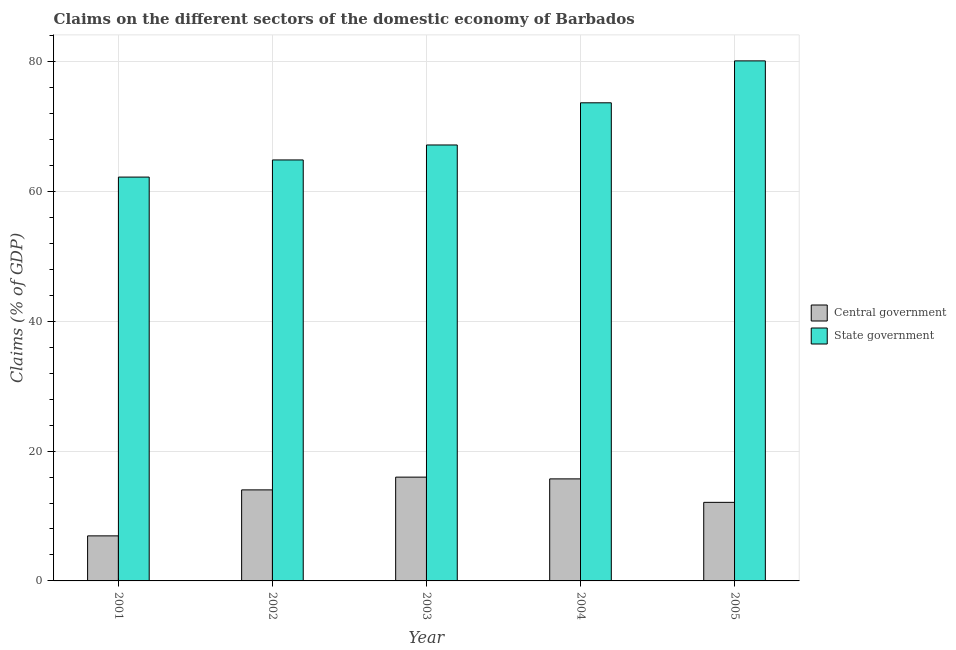How many different coloured bars are there?
Keep it short and to the point. 2. Are the number of bars per tick equal to the number of legend labels?
Offer a very short reply. Yes. Are the number of bars on each tick of the X-axis equal?
Keep it short and to the point. Yes. How many bars are there on the 1st tick from the right?
Provide a short and direct response. 2. What is the claims on state government in 2004?
Your response must be concise. 73.65. Across all years, what is the maximum claims on central government?
Make the answer very short. 15.99. Across all years, what is the minimum claims on central government?
Your answer should be very brief. 6.94. In which year was the claims on central government maximum?
Your response must be concise. 2003. In which year was the claims on central government minimum?
Provide a short and direct response. 2001. What is the total claims on central government in the graph?
Give a very brief answer. 64.77. What is the difference between the claims on central government in 2001 and that in 2003?
Your answer should be very brief. -9.05. What is the difference between the claims on state government in 2001 and the claims on central government in 2003?
Make the answer very short. -4.95. What is the average claims on central government per year?
Offer a very short reply. 12.95. What is the ratio of the claims on state government in 2002 to that in 2003?
Your response must be concise. 0.97. Is the claims on state government in 2001 less than that in 2002?
Ensure brevity in your answer.  Yes. What is the difference between the highest and the second highest claims on state government?
Offer a very short reply. 6.46. What is the difference between the highest and the lowest claims on central government?
Ensure brevity in your answer.  9.05. In how many years, is the claims on central government greater than the average claims on central government taken over all years?
Give a very brief answer. 3. What does the 2nd bar from the left in 2004 represents?
Provide a short and direct response. State government. What does the 1st bar from the right in 2003 represents?
Provide a succinct answer. State government. How many bars are there?
Ensure brevity in your answer.  10. Does the graph contain any zero values?
Provide a short and direct response. No. How many legend labels are there?
Provide a short and direct response. 2. How are the legend labels stacked?
Offer a very short reply. Vertical. What is the title of the graph?
Your answer should be very brief. Claims on the different sectors of the domestic economy of Barbados. Does "From human activities" appear as one of the legend labels in the graph?
Ensure brevity in your answer.  No. What is the label or title of the X-axis?
Your answer should be very brief. Year. What is the label or title of the Y-axis?
Ensure brevity in your answer.  Claims (% of GDP). What is the Claims (% of GDP) of Central government in 2001?
Provide a short and direct response. 6.94. What is the Claims (% of GDP) in State government in 2001?
Your response must be concise. 62.21. What is the Claims (% of GDP) in Central government in 2002?
Offer a very short reply. 14.02. What is the Claims (% of GDP) of State government in 2002?
Provide a succinct answer. 64.85. What is the Claims (% of GDP) of Central government in 2003?
Keep it short and to the point. 15.99. What is the Claims (% of GDP) of State government in 2003?
Give a very brief answer. 67.15. What is the Claims (% of GDP) of Central government in 2004?
Provide a short and direct response. 15.72. What is the Claims (% of GDP) of State government in 2004?
Ensure brevity in your answer.  73.65. What is the Claims (% of GDP) of Central government in 2005?
Make the answer very short. 12.1. What is the Claims (% of GDP) of State government in 2005?
Provide a short and direct response. 80.11. Across all years, what is the maximum Claims (% of GDP) of Central government?
Your response must be concise. 15.99. Across all years, what is the maximum Claims (% of GDP) of State government?
Provide a short and direct response. 80.11. Across all years, what is the minimum Claims (% of GDP) of Central government?
Offer a very short reply. 6.94. Across all years, what is the minimum Claims (% of GDP) in State government?
Keep it short and to the point. 62.21. What is the total Claims (% of GDP) of Central government in the graph?
Your answer should be compact. 64.77. What is the total Claims (% of GDP) of State government in the graph?
Make the answer very short. 347.97. What is the difference between the Claims (% of GDP) in Central government in 2001 and that in 2002?
Give a very brief answer. -7.08. What is the difference between the Claims (% of GDP) in State government in 2001 and that in 2002?
Give a very brief answer. -2.64. What is the difference between the Claims (% of GDP) in Central government in 2001 and that in 2003?
Keep it short and to the point. -9.05. What is the difference between the Claims (% of GDP) of State government in 2001 and that in 2003?
Provide a short and direct response. -4.95. What is the difference between the Claims (% of GDP) in Central government in 2001 and that in 2004?
Your answer should be very brief. -8.78. What is the difference between the Claims (% of GDP) in State government in 2001 and that in 2004?
Keep it short and to the point. -11.44. What is the difference between the Claims (% of GDP) of Central government in 2001 and that in 2005?
Offer a very short reply. -5.16. What is the difference between the Claims (% of GDP) in State government in 2001 and that in 2005?
Keep it short and to the point. -17.9. What is the difference between the Claims (% of GDP) of Central government in 2002 and that in 2003?
Make the answer very short. -1.97. What is the difference between the Claims (% of GDP) in State government in 2002 and that in 2003?
Give a very brief answer. -2.31. What is the difference between the Claims (% of GDP) of Central government in 2002 and that in 2004?
Ensure brevity in your answer.  -1.7. What is the difference between the Claims (% of GDP) in State government in 2002 and that in 2004?
Ensure brevity in your answer.  -8.8. What is the difference between the Claims (% of GDP) in Central government in 2002 and that in 2005?
Your response must be concise. 1.92. What is the difference between the Claims (% of GDP) in State government in 2002 and that in 2005?
Keep it short and to the point. -15.26. What is the difference between the Claims (% of GDP) of Central government in 2003 and that in 2004?
Provide a succinct answer. 0.27. What is the difference between the Claims (% of GDP) of State government in 2003 and that in 2004?
Your response must be concise. -6.5. What is the difference between the Claims (% of GDP) in Central government in 2003 and that in 2005?
Provide a short and direct response. 3.88. What is the difference between the Claims (% of GDP) of State government in 2003 and that in 2005?
Keep it short and to the point. -12.95. What is the difference between the Claims (% of GDP) in Central government in 2004 and that in 2005?
Ensure brevity in your answer.  3.62. What is the difference between the Claims (% of GDP) of State government in 2004 and that in 2005?
Provide a short and direct response. -6.46. What is the difference between the Claims (% of GDP) in Central government in 2001 and the Claims (% of GDP) in State government in 2002?
Offer a terse response. -57.91. What is the difference between the Claims (% of GDP) in Central government in 2001 and the Claims (% of GDP) in State government in 2003?
Provide a short and direct response. -60.21. What is the difference between the Claims (% of GDP) in Central government in 2001 and the Claims (% of GDP) in State government in 2004?
Ensure brevity in your answer.  -66.71. What is the difference between the Claims (% of GDP) of Central government in 2001 and the Claims (% of GDP) of State government in 2005?
Provide a succinct answer. -73.17. What is the difference between the Claims (% of GDP) of Central government in 2002 and the Claims (% of GDP) of State government in 2003?
Provide a short and direct response. -53.13. What is the difference between the Claims (% of GDP) in Central government in 2002 and the Claims (% of GDP) in State government in 2004?
Your answer should be compact. -59.63. What is the difference between the Claims (% of GDP) of Central government in 2002 and the Claims (% of GDP) of State government in 2005?
Ensure brevity in your answer.  -66.09. What is the difference between the Claims (% of GDP) in Central government in 2003 and the Claims (% of GDP) in State government in 2004?
Offer a very short reply. -57.66. What is the difference between the Claims (% of GDP) of Central government in 2003 and the Claims (% of GDP) of State government in 2005?
Provide a short and direct response. -64.12. What is the difference between the Claims (% of GDP) of Central government in 2004 and the Claims (% of GDP) of State government in 2005?
Your answer should be compact. -64.39. What is the average Claims (% of GDP) of Central government per year?
Your answer should be very brief. 12.95. What is the average Claims (% of GDP) of State government per year?
Offer a terse response. 69.59. In the year 2001, what is the difference between the Claims (% of GDP) of Central government and Claims (% of GDP) of State government?
Provide a succinct answer. -55.27. In the year 2002, what is the difference between the Claims (% of GDP) in Central government and Claims (% of GDP) in State government?
Make the answer very short. -50.83. In the year 2003, what is the difference between the Claims (% of GDP) of Central government and Claims (% of GDP) of State government?
Make the answer very short. -51.17. In the year 2004, what is the difference between the Claims (% of GDP) of Central government and Claims (% of GDP) of State government?
Your answer should be compact. -57.93. In the year 2005, what is the difference between the Claims (% of GDP) in Central government and Claims (% of GDP) in State government?
Offer a very short reply. -68. What is the ratio of the Claims (% of GDP) in Central government in 2001 to that in 2002?
Your answer should be compact. 0.49. What is the ratio of the Claims (% of GDP) in State government in 2001 to that in 2002?
Your answer should be very brief. 0.96. What is the ratio of the Claims (% of GDP) in Central government in 2001 to that in 2003?
Provide a succinct answer. 0.43. What is the ratio of the Claims (% of GDP) in State government in 2001 to that in 2003?
Your answer should be compact. 0.93. What is the ratio of the Claims (% of GDP) of Central government in 2001 to that in 2004?
Make the answer very short. 0.44. What is the ratio of the Claims (% of GDP) of State government in 2001 to that in 2004?
Provide a succinct answer. 0.84. What is the ratio of the Claims (% of GDP) in Central government in 2001 to that in 2005?
Offer a very short reply. 0.57. What is the ratio of the Claims (% of GDP) in State government in 2001 to that in 2005?
Ensure brevity in your answer.  0.78. What is the ratio of the Claims (% of GDP) in Central government in 2002 to that in 2003?
Provide a succinct answer. 0.88. What is the ratio of the Claims (% of GDP) in State government in 2002 to that in 2003?
Offer a terse response. 0.97. What is the ratio of the Claims (% of GDP) in Central government in 2002 to that in 2004?
Keep it short and to the point. 0.89. What is the ratio of the Claims (% of GDP) in State government in 2002 to that in 2004?
Your answer should be very brief. 0.88. What is the ratio of the Claims (% of GDP) in Central government in 2002 to that in 2005?
Make the answer very short. 1.16. What is the ratio of the Claims (% of GDP) of State government in 2002 to that in 2005?
Provide a succinct answer. 0.81. What is the ratio of the Claims (% of GDP) of Central government in 2003 to that in 2004?
Your response must be concise. 1.02. What is the ratio of the Claims (% of GDP) in State government in 2003 to that in 2004?
Give a very brief answer. 0.91. What is the ratio of the Claims (% of GDP) of Central government in 2003 to that in 2005?
Ensure brevity in your answer.  1.32. What is the ratio of the Claims (% of GDP) of State government in 2003 to that in 2005?
Ensure brevity in your answer.  0.84. What is the ratio of the Claims (% of GDP) in Central government in 2004 to that in 2005?
Provide a short and direct response. 1.3. What is the ratio of the Claims (% of GDP) in State government in 2004 to that in 2005?
Your answer should be compact. 0.92. What is the difference between the highest and the second highest Claims (% of GDP) in Central government?
Ensure brevity in your answer.  0.27. What is the difference between the highest and the second highest Claims (% of GDP) of State government?
Ensure brevity in your answer.  6.46. What is the difference between the highest and the lowest Claims (% of GDP) in Central government?
Offer a very short reply. 9.05. What is the difference between the highest and the lowest Claims (% of GDP) of State government?
Provide a short and direct response. 17.9. 